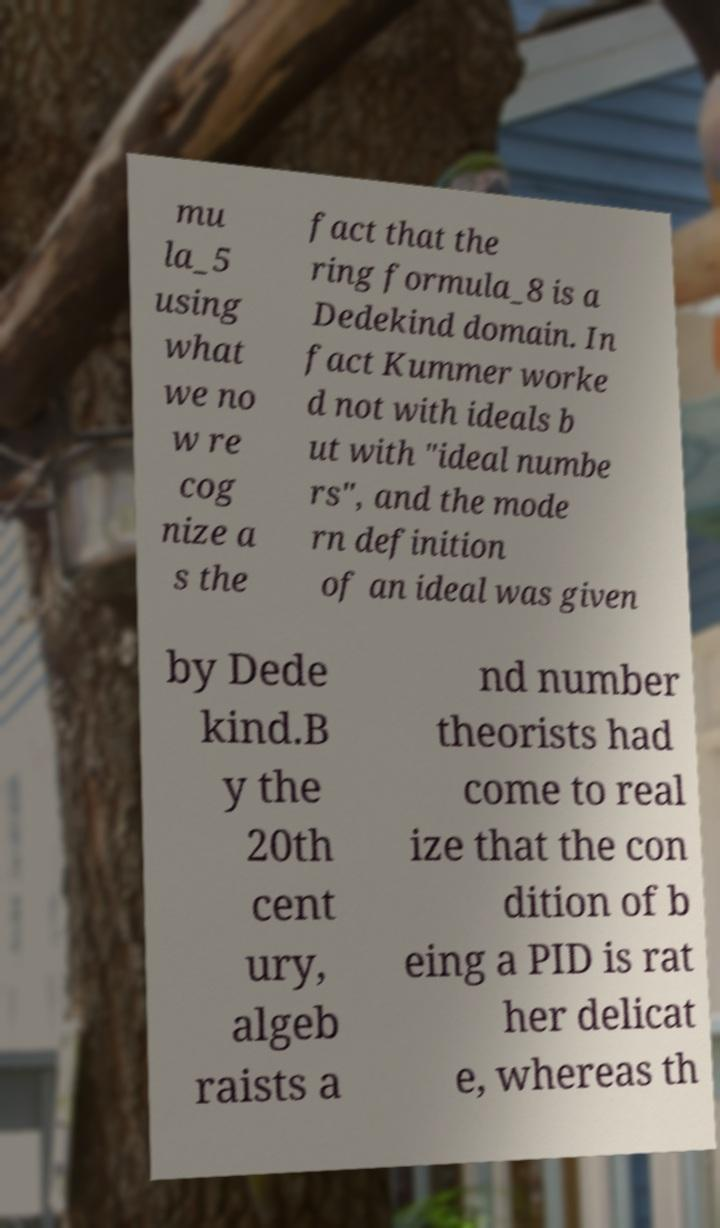Please identify and transcribe the text found in this image. mu la_5 using what we no w re cog nize a s the fact that the ring formula_8 is a Dedekind domain. In fact Kummer worke d not with ideals b ut with "ideal numbe rs", and the mode rn definition of an ideal was given by Dede kind.B y the 20th cent ury, algeb raists a nd number theorists had come to real ize that the con dition of b eing a PID is rat her delicat e, whereas th 